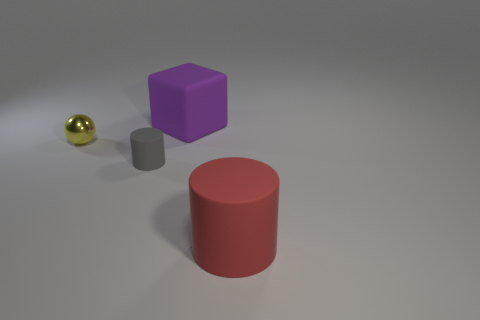Is there another tiny thing that has the same material as the purple object?
Keep it short and to the point. Yes. There is a big object that is on the left side of the cylinder right of the purple matte thing; are there any yellow spheres that are right of it?
Make the answer very short. No. Are there any large cylinders left of the red cylinder?
Ensure brevity in your answer.  No. How many purple blocks are to the right of the large rubber thing that is in front of the tiny gray rubber thing?
Offer a very short reply. 0. There is a purple rubber cube; is it the same size as the object on the left side of the gray object?
Give a very brief answer. No. Is there a tiny metal thing that has the same color as the tiny cylinder?
Your answer should be compact. No. There is a gray thing that is the same material as the big cube; what size is it?
Make the answer very short. Small. Is the cube made of the same material as the gray cylinder?
Make the answer very short. Yes. The cylinder on the right side of the rubber cylinder that is to the left of the large object that is behind the red rubber object is what color?
Ensure brevity in your answer.  Red. What shape is the yellow shiny object?
Provide a succinct answer. Sphere. 